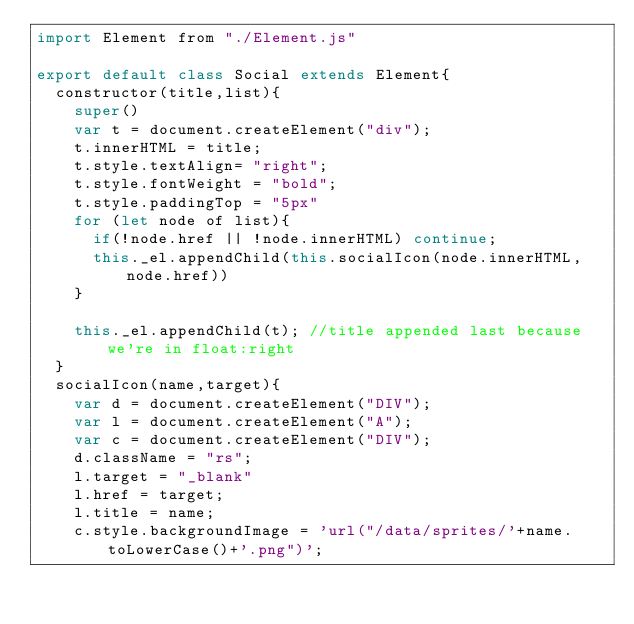<code> <loc_0><loc_0><loc_500><loc_500><_JavaScript_>import Element from "./Element.js"

export default class Social extends Element{
  constructor(title,list){
    super()
    var t = document.createElement("div");
    t.innerHTML = title;
    t.style.textAlign= "right";
    t.style.fontWeight = "bold";
    t.style.paddingTop = "5px"
    for (let node of list){
      if(!node.href || !node.innerHTML) continue;
      this._el.appendChild(this.socialIcon(node.innerHTML,node.href))
    }

    this._el.appendChild(t); //title appended last because we're in float:right
  }
  socialIcon(name,target){
    var d = document.createElement("DIV");
    var l = document.createElement("A");
    var c = document.createElement("DIV");
    d.className = "rs";
    l.target = "_blank"
    l.href = target;
    l.title = name;
    c.style.backgroundImage = 'url("/data/sprites/'+name.toLowerCase()+'.png")';</code> 